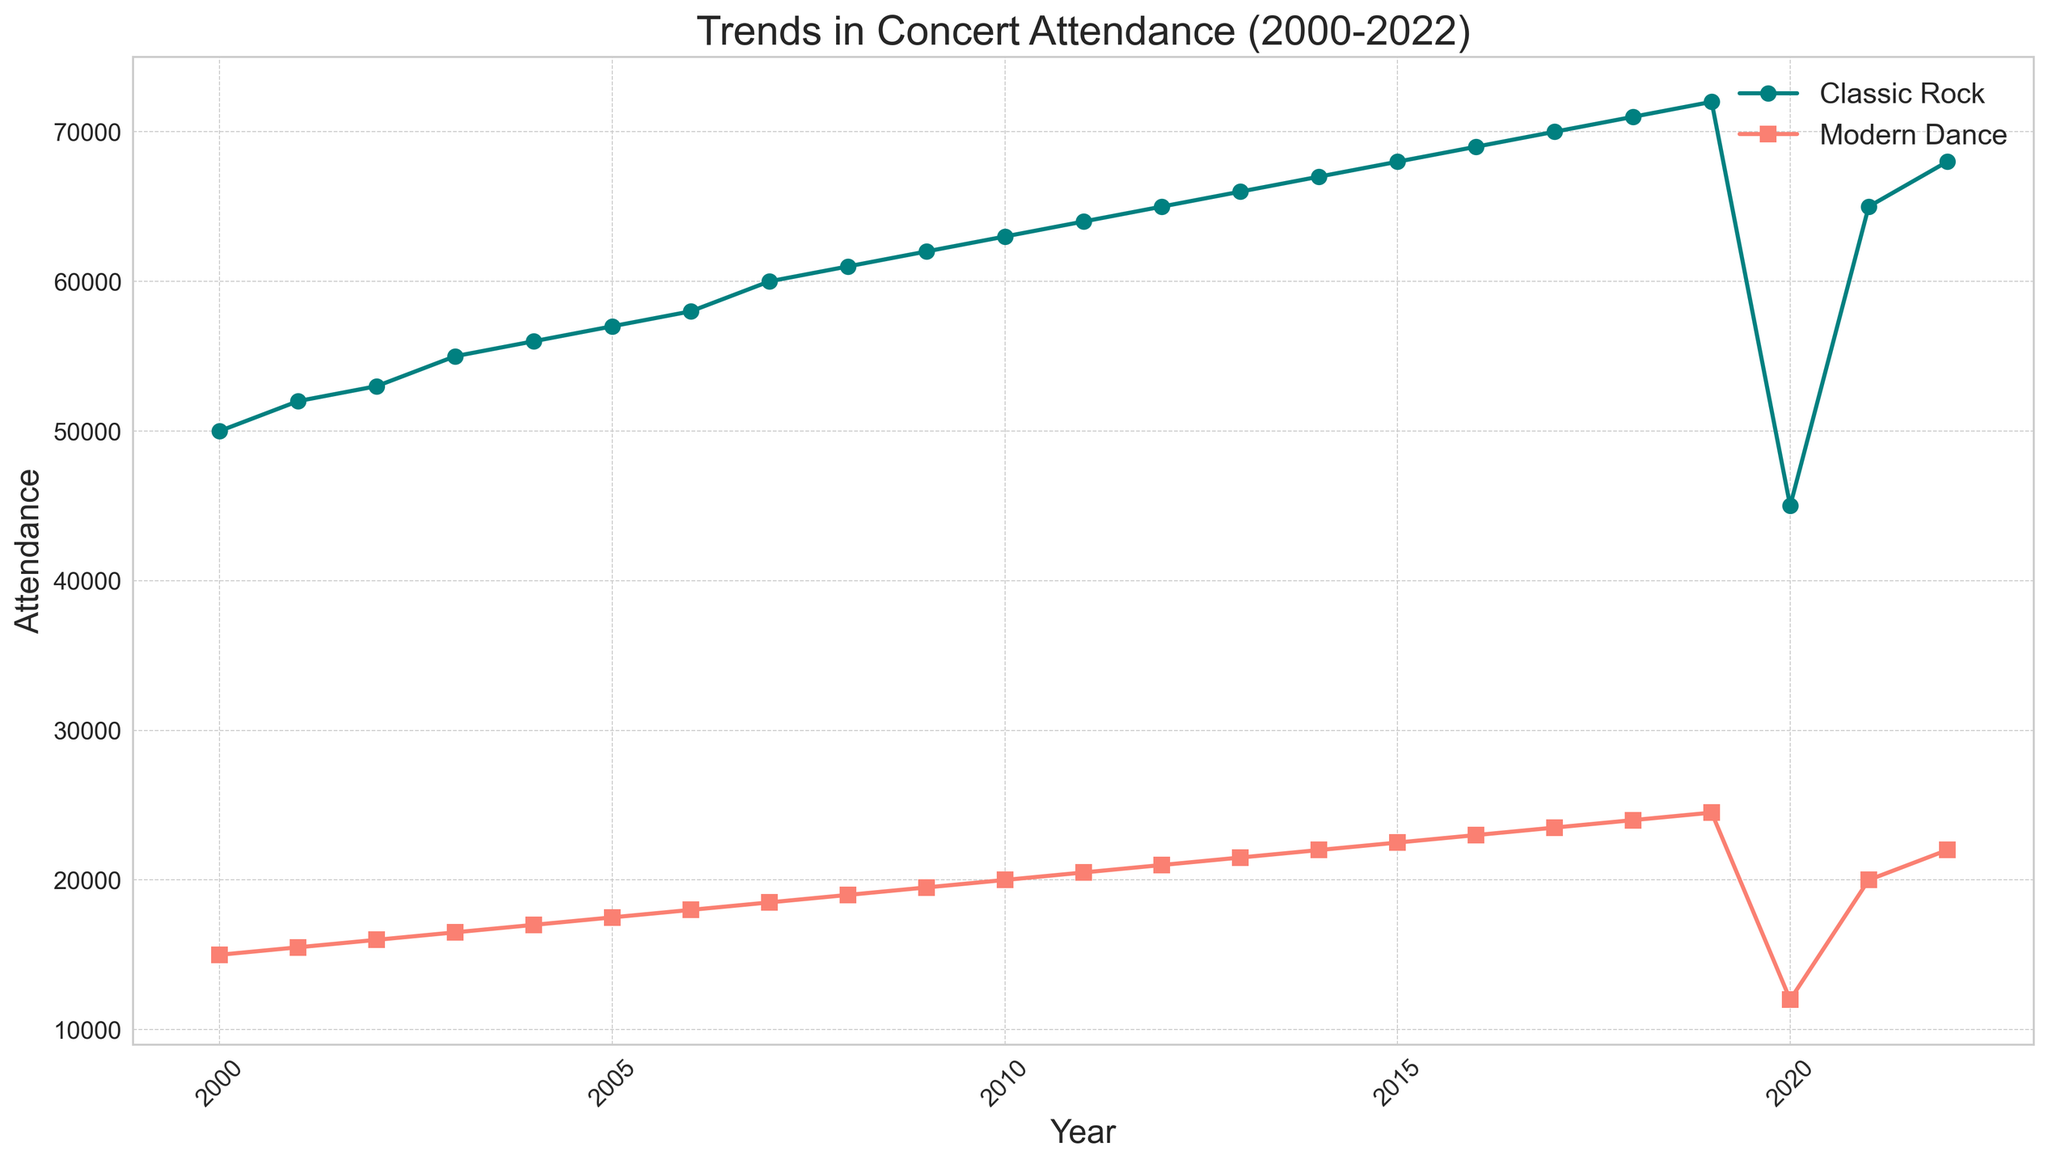What year saw the highest attendance for classic rock concerts? By looking at the plot, identify the peak point for classic rock and note the corresponding year.
Answer: 2019 What was the attendance for modern dance performances in 2020, and how does it compare to 2019? Locate the attendance values for modern dance in both 2019 and 2020 on the plot, then calculate the difference.
Answer: 12000, 12500 less In which year was the gap between classic rock and modern dance attendance the smallest? Find the years where the lines for classic rock and modern dance are closest together and compare their attendance values to identify the smallest gap.
Answer: 2020 What is the overall trend in attendance for classic rock concerts from 2000 to 2022? Analyze the shape of the line for classic rock over the entire period, noting the general direction and any significant changes.
Answer: Increasing trend with a dip in 2020 By how much did the attendance for modern dance increase from 2000 to 2022? Identify the attendance values for modern dance in 2000 and 2022, then subtract the 2000 value from the 2022 value.
Answer: 7000 In which year did both concert types see a similar trend, even though the attendance numbers were different? Look for years where both lines either rise or fall together, indicating a similar trend despite the difference in absolute numbers.
Answer: 2020 Between 2000 and 2015, which concert type saw a larger relative increase in attendance? Calculate the percentage increase for both concert types from 2000 to 2015, then compare these percentages.
Answer: Modern dance How does the attendance trend of modern dance performances compare visually to that of classic rock concerts? Describe the visual characteristics of both lines, noting similarities or differences in shape, growth, and any noticeable patterns.
Answer: Both increase steadily with a dip in 2020 In which year did classic rock concerts reach an attendance of 70000? Look at the plot and identify the year where the classic rock line hits the 70000 mark.
Answer: 2017 What was the average attendance for classic rock concerts from 2000 to 2015? Sum the attendance values for classic rock from 2000 to 2015 and divide by the number of years (16).
Answer: 58000 